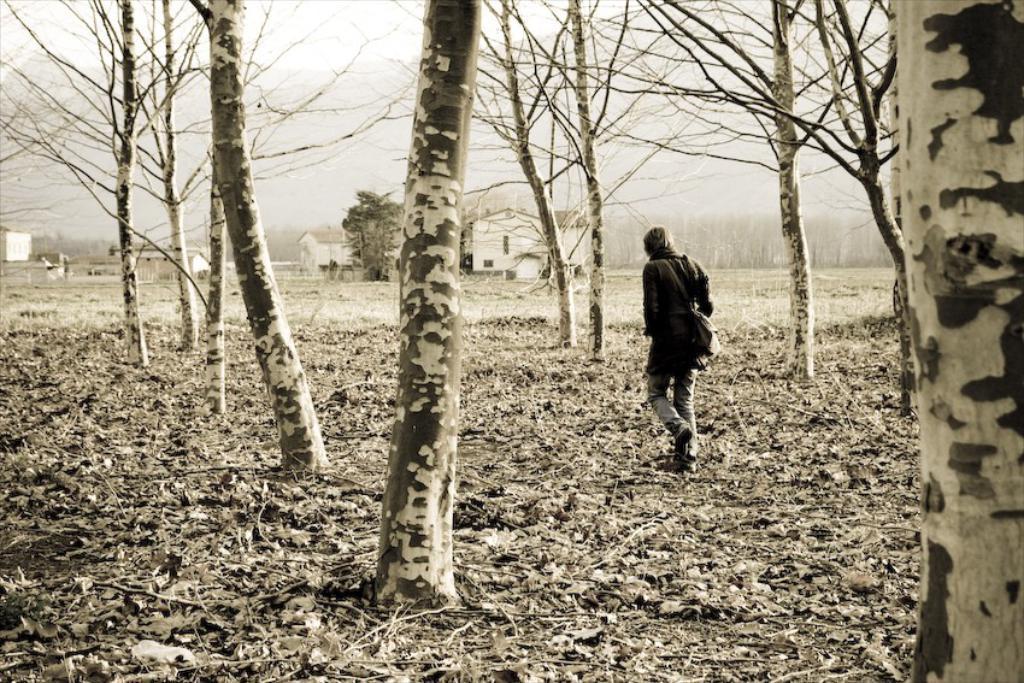Please provide a concise description of this image. This is an edited image. In the center of the image we can see a person is walking on the ground and wearing a jacket, bag. In the background of the image we can see the trees, buildings. At the top of the image we can see the sky. At the bottom of the image we can see the dry leaves and twigs. 